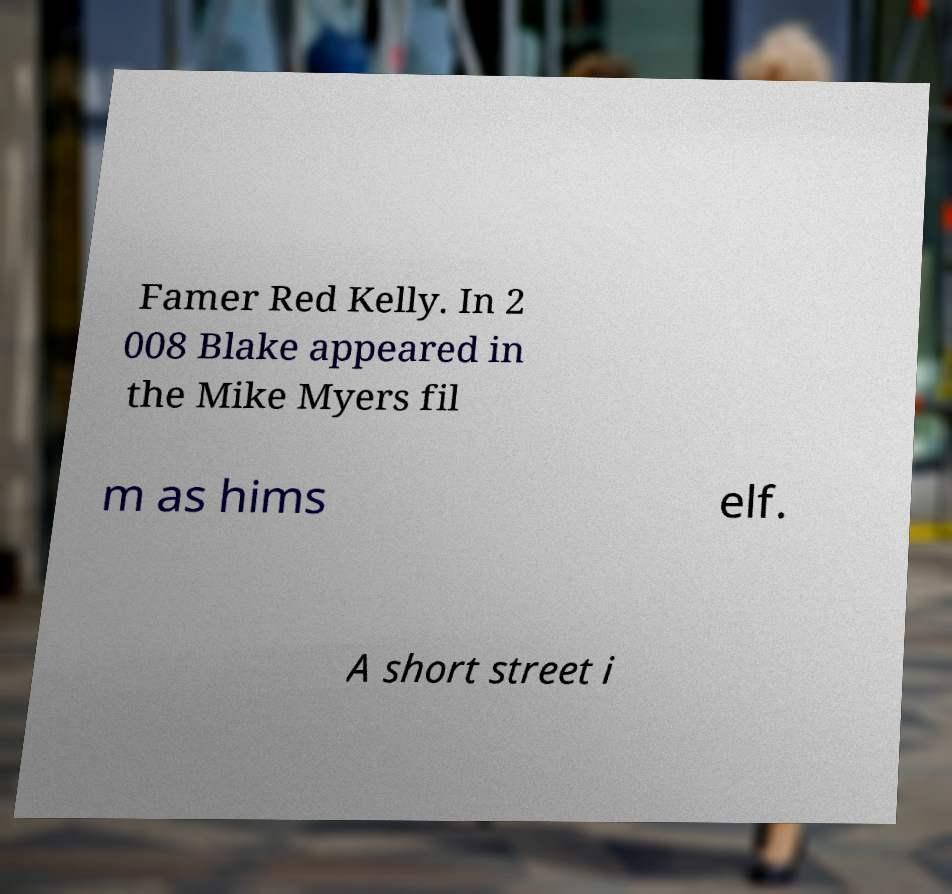There's text embedded in this image that I need extracted. Can you transcribe it verbatim? Famer Red Kelly. In 2 008 Blake appeared in the Mike Myers fil m as hims elf. A short street i 